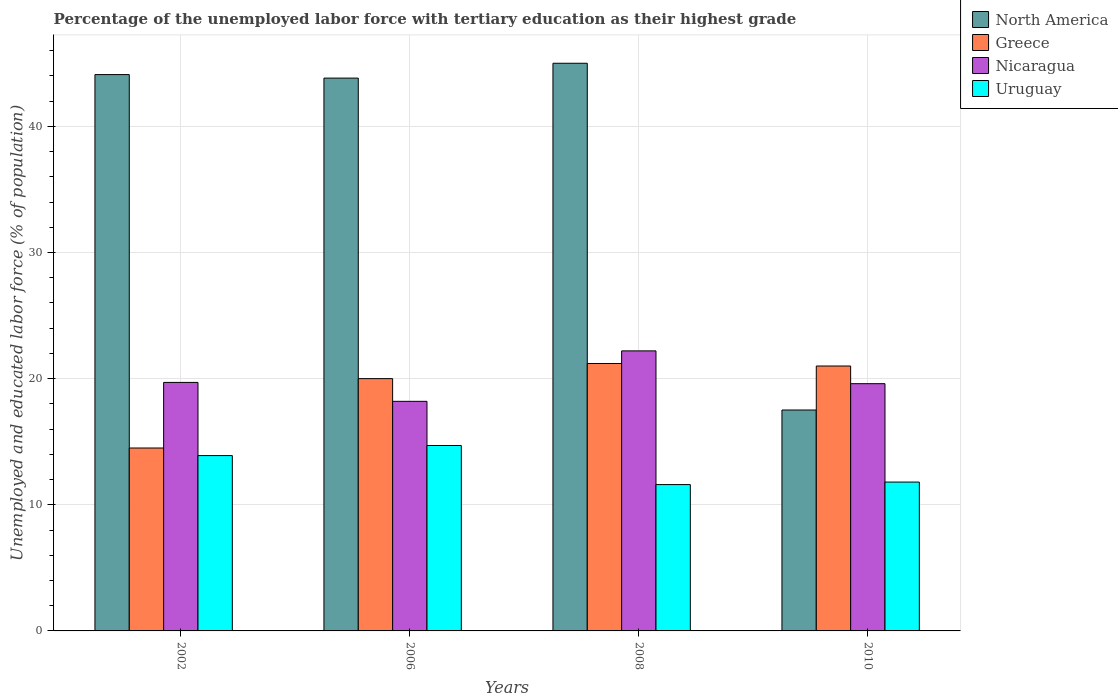How many groups of bars are there?
Ensure brevity in your answer.  4. Are the number of bars on each tick of the X-axis equal?
Make the answer very short. Yes. How many bars are there on the 1st tick from the right?
Your response must be concise. 4. What is the percentage of the unemployed labor force with tertiary education in Greece in 2008?
Provide a short and direct response. 21.2. Across all years, what is the maximum percentage of the unemployed labor force with tertiary education in North America?
Your response must be concise. 45. Across all years, what is the minimum percentage of the unemployed labor force with tertiary education in Nicaragua?
Make the answer very short. 18.2. In which year was the percentage of the unemployed labor force with tertiary education in Uruguay minimum?
Your answer should be very brief. 2008. What is the total percentage of the unemployed labor force with tertiary education in North America in the graph?
Your answer should be compact. 150.44. What is the difference between the percentage of the unemployed labor force with tertiary education in North America in 2002 and that in 2010?
Ensure brevity in your answer.  26.59. What is the difference between the percentage of the unemployed labor force with tertiary education in Nicaragua in 2006 and the percentage of the unemployed labor force with tertiary education in Greece in 2002?
Keep it short and to the point. 3.7. What is the average percentage of the unemployed labor force with tertiary education in Nicaragua per year?
Your answer should be compact. 19.93. In the year 2008, what is the difference between the percentage of the unemployed labor force with tertiary education in Uruguay and percentage of the unemployed labor force with tertiary education in Nicaragua?
Keep it short and to the point. -10.6. In how many years, is the percentage of the unemployed labor force with tertiary education in Uruguay greater than 26 %?
Provide a short and direct response. 0. What is the ratio of the percentage of the unemployed labor force with tertiary education in Greece in 2002 to that in 2010?
Offer a very short reply. 0.69. Is the percentage of the unemployed labor force with tertiary education in Nicaragua in 2008 less than that in 2010?
Give a very brief answer. No. Is the difference between the percentage of the unemployed labor force with tertiary education in Uruguay in 2008 and 2010 greater than the difference between the percentage of the unemployed labor force with tertiary education in Nicaragua in 2008 and 2010?
Ensure brevity in your answer.  No. What is the difference between the highest and the second highest percentage of the unemployed labor force with tertiary education in Nicaragua?
Give a very brief answer. 2.5. What is the difference between the highest and the lowest percentage of the unemployed labor force with tertiary education in Uruguay?
Give a very brief answer. 3.1. In how many years, is the percentage of the unemployed labor force with tertiary education in Nicaragua greater than the average percentage of the unemployed labor force with tertiary education in Nicaragua taken over all years?
Offer a terse response. 1. Is the sum of the percentage of the unemployed labor force with tertiary education in Greece in 2006 and 2008 greater than the maximum percentage of the unemployed labor force with tertiary education in North America across all years?
Keep it short and to the point. No. Is it the case that in every year, the sum of the percentage of the unemployed labor force with tertiary education in Uruguay and percentage of the unemployed labor force with tertiary education in North America is greater than the sum of percentage of the unemployed labor force with tertiary education in Nicaragua and percentage of the unemployed labor force with tertiary education in Greece?
Give a very brief answer. No. What does the 3rd bar from the left in 2010 represents?
Ensure brevity in your answer.  Nicaragua. What does the 4th bar from the right in 2008 represents?
Your answer should be compact. North America. How many years are there in the graph?
Provide a short and direct response. 4. Are the values on the major ticks of Y-axis written in scientific E-notation?
Your answer should be compact. No. Does the graph contain any zero values?
Your response must be concise. No. Where does the legend appear in the graph?
Provide a succinct answer. Top right. How many legend labels are there?
Your response must be concise. 4. What is the title of the graph?
Your response must be concise. Percentage of the unemployed labor force with tertiary education as their highest grade. Does "Spain" appear as one of the legend labels in the graph?
Your answer should be compact. No. What is the label or title of the Y-axis?
Provide a succinct answer. Unemployed and educated labor force (% of population). What is the Unemployed and educated labor force (% of population) in North America in 2002?
Make the answer very short. 44.1. What is the Unemployed and educated labor force (% of population) in Greece in 2002?
Your answer should be compact. 14.5. What is the Unemployed and educated labor force (% of population) in Nicaragua in 2002?
Offer a terse response. 19.7. What is the Unemployed and educated labor force (% of population) of Uruguay in 2002?
Offer a terse response. 13.9. What is the Unemployed and educated labor force (% of population) of North America in 2006?
Offer a very short reply. 43.82. What is the Unemployed and educated labor force (% of population) in Nicaragua in 2006?
Ensure brevity in your answer.  18.2. What is the Unemployed and educated labor force (% of population) of Uruguay in 2006?
Keep it short and to the point. 14.7. What is the Unemployed and educated labor force (% of population) in North America in 2008?
Offer a terse response. 45. What is the Unemployed and educated labor force (% of population) in Greece in 2008?
Offer a very short reply. 21.2. What is the Unemployed and educated labor force (% of population) in Nicaragua in 2008?
Provide a short and direct response. 22.2. What is the Unemployed and educated labor force (% of population) of Uruguay in 2008?
Your response must be concise. 11.6. What is the Unemployed and educated labor force (% of population) of North America in 2010?
Ensure brevity in your answer.  17.51. What is the Unemployed and educated labor force (% of population) in Nicaragua in 2010?
Offer a very short reply. 19.6. What is the Unemployed and educated labor force (% of population) of Uruguay in 2010?
Give a very brief answer. 11.8. Across all years, what is the maximum Unemployed and educated labor force (% of population) in North America?
Keep it short and to the point. 45. Across all years, what is the maximum Unemployed and educated labor force (% of population) of Greece?
Ensure brevity in your answer.  21.2. Across all years, what is the maximum Unemployed and educated labor force (% of population) in Nicaragua?
Provide a succinct answer. 22.2. Across all years, what is the maximum Unemployed and educated labor force (% of population) of Uruguay?
Give a very brief answer. 14.7. Across all years, what is the minimum Unemployed and educated labor force (% of population) in North America?
Your response must be concise. 17.51. Across all years, what is the minimum Unemployed and educated labor force (% of population) in Nicaragua?
Provide a succinct answer. 18.2. Across all years, what is the minimum Unemployed and educated labor force (% of population) in Uruguay?
Ensure brevity in your answer.  11.6. What is the total Unemployed and educated labor force (% of population) in North America in the graph?
Your answer should be very brief. 150.44. What is the total Unemployed and educated labor force (% of population) of Greece in the graph?
Ensure brevity in your answer.  76.7. What is the total Unemployed and educated labor force (% of population) of Nicaragua in the graph?
Offer a very short reply. 79.7. What is the total Unemployed and educated labor force (% of population) of Uruguay in the graph?
Offer a very short reply. 52. What is the difference between the Unemployed and educated labor force (% of population) of North America in 2002 and that in 2006?
Give a very brief answer. 0.28. What is the difference between the Unemployed and educated labor force (% of population) of Greece in 2002 and that in 2006?
Make the answer very short. -5.5. What is the difference between the Unemployed and educated labor force (% of population) of North America in 2002 and that in 2008?
Your answer should be compact. -0.9. What is the difference between the Unemployed and educated labor force (% of population) of Greece in 2002 and that in 2008?
Give a very brief answer. -6.7. What is the difference between the Unemployed and educated labor force (% of population) of Uruguay in 2002 and that in 2008?
Give a very brief answer. 2.3. What is the difference between the Unemployed and educated labor force (% of population) in North America in 2002 and that in 2010?
Offer a terse response. 26.59. What is the difference between the Unemployed and educated labor force (% of population) of Greece in 2002 and that in 2010?
Your answer should be compact. -6.5. What is the difference between the Unemployed and educated labor force (% of population) of Nicaragua in 2002 and that in 2010?
Ensure brevity in your answer.  0.1. What is the difference between the Unemployed and educated labor force (% of population) in Uruguay in 2002 and that in 2010?
Provide a short and direct response. 2.1. What is the difference between the Unemployed and educated labor force (% of population) in North America in 2006 and that in 2008?
Your answer should be compact. -1.18. What is the difference between the Unemployed and educated labor force (% of population) in Nicaragua in 2006 and that in 2008?
Your response must be concise. -4. What is the difference between the Unemployed and educated labor force (% of population) in North America in 2006 and that in 2010?
Your response must be concise. 26.31. What is the difference between the Unemployed and educated labor force (% of population) of North America in 2008 and that in 2010?
Ensure brevity in your answer.  27.49. What is the difference between the Unemployed and educated labor force (% of population) of Greece in 2008 and that in 2010?
Keep it short and to the point. 0.2. What is the difference between the Unemployed and educated labor force (% of population) of North America in 2002 and the Unemployed and educated labor force (% of population) of Greece in 2006?
Your answer should be very brief. 24.1. What is the difference between the Unemployed and educated labor force (% of population) in North America in 2002 and the Unemployed and educated labor force (% of population) in Nicaragua in 2006?
Give a very brief answer. 25.9. What is the difference between the Unemployed and educated labor force (% of population) of North America in 2002 and the Unemployed and educated labor force (% of population) of Uruguay in 2006?
Keep it short and to the point. 29.4. What is the difference between the Unemployed and educated labor force (% of population) in Greece in 2002 and the Unemployed and educated labor force (% of population) in Uruguay in 2006?
Give a very brief answer. -0.2. What is the difference between the Unemployed and educated labor force (% of population) of Nicaragua in 2002 and the Unemployed and educated labor force (% of population) of Uruguay in 2006?
Ensure brevity in your answer.  5. What is the difference between the Unemployed and educated labor force (% of population) of North America in 2002 and the Unemployed and educated labor force (% of population) of Greece in 2008?
Ensure brevity in your answer.  22.9. What is the difference between the Unemployed and educated labor force (% of population) in North America in 2002 and the Unemployed and educated labor force (% of population) in Nicaragua in 2008?
Your answer should be very brief. 21.9. What is the difference between the Unemployed and educated labor force (% of population) of North America in 2002 and the Unemployed and educated labor force (% of population) of Uruguay in 2008?
Your answer should be compact. 32.5. What is the difference between the Unemployed and educated labor force (% of population) of North America in 2002 and the Unemployed and educated labor force (% of population) of Greece in 2010?
Your answer should be very brief. 23.1. What is the difference between the Unemployed and educated labor force (% of population) in North America in 2002 and the Unemployed and educated labor force (% of population) in Nicaragua in 2010?
Offer a very short reply. 24.5. What is the difference between the Unemployed and educated labor force (% of population) in North America in 2002 and the Unemployed and educated labor force (% of population) in Uruguay in 2010?
Your answer should be compact. 32.3. What is the difference between the Unemployed and educated labor force (% of population) in North America in 2006 and the Unemployed and educated labor force (% of population) in Greece in 2008?
Provide a succinct answer. 22.62. What is the difference between the Unemployed and educated labor force (% of population) in North America in 2006 and the Unemployed and educated labor force (% of population) in Nicaragua in 2008?
Offer a very short reply. 21.62. What is the difference between the Unemployed and educated labor force (% of population) in North America in 2006 and the Unemployed and educated labor force (% of population) in Uruguay in 2008?
Make the answer very short. 32.22. What is the difference between the Unemployed and educated labor force (% of population) of Greece in 2006 and the Unemployed and educated labor force (% of population) of Nicaragua in 2008?
Offer a very short reply. -2.2. What is the difference between the Unemployed and educated labor force (% of population) of Nicaragua in 2006 and the Unemployed and educated labor force (% of population) of Uruguay in 2008?
Give a very brief answer. 6.6. What is the difference between the Unemployed and educated labor force (% of population) in North America in 2006 and the Unemployed and educated labor force (% of population) in Greece in 2010?
Provide a short and direct response. 22.82. What is the difference between the Unemployed and educated labor force (% of population) in North America in 2006 and the Unemployed and educated labor force (% of population) in Nicaragua in 2010?
Offer a terse response. 24.22. What is the difference between the Unemployed and educated labor force (% of population) in North America in 2006 and the Unemployed and educated labor force (% of population) in Uruguay in 2010?
Your answer should be compact. 32.02. What is the difference between the Unemployed and educated labor force (% of population) in Greece in 2006 and the Unemployed and educated labor force (% of population) in Nicaragua in 2010?
Make the answer very short. 0.4. What is the difference between the Unemployed and educated labor force (% of population) of Nicaragua in 2006 and the Unemployed and educated labor force (% of population) of Uruguay in 2010?
Offer a very short reply. 6.4. What is the difference between the Unemployed and educated labor force (% of population) in North America in 2008 and the Unemployed and educated labor force (% of population) in Greece in 2010?
Give a very brief answer. 24. What is the difference between the Unemployed and educated labor force (% of population) in North America in 2008 and the Unemployed and educated labor force (% of population) in Nicaragua in 2010?
Make the answer very short. 25.4. What is the difference between the Unemployed and educated labor force (% of population) of North America in 2008 and the Unemployed and educated labor force (% of population) of Uruguay in 2010?
Your answer should be very brief. 33.2. What is the difference between the Unemployed and educated labor force (% of population) of Greece in 2008 and the Unemployed and educated labor force (% of population) of Uruguay in 2010?
Ensure brevity in your answer.  9.4. What is the difference between the Unemployed and educated labor force (% of population) in Nicaragua in 2008 and the Unemployed and educated labor force (% of population) in Uruguay in 2010?
Provide a short and direct response. 10.4. What is the average Unemployed and educated labor force (% of population) of North America per year?
Your response must be concise. 37.61. What is the average Unemployed and educated labor force (% of population) in Greece per year?
Offer a very short reply. 19.18. What is the average Unemployed and educated labor force (% of population) in Nicaragua per year?
Make the answer very short. 19.93. What is the average Unemployed and educated labor force (% of population) in Uruguay per year?
Your answer should be compact. 13. In the year 2002, what is the difference between the Unemployed and educated labor force (% of population) in North America and Unemployed and educated labor force (% of population) in Greece?
Your response must be concise. 29.6. In the year 2002, what is the difference between the Unemployed and educated labor force (% of population) of North America and Unemployed and educated labor force (% of population) of Nicaragua?
Keep it short and to the point. 24.4. In the year 2002, what is the difference between the Unemployed and educated labor force (% of population) in North America and Unemployed and educated labor force (% of population) in Uruguay?
Offer a terse response. 30.2. In the year 2006, what is the difference between the Unemployed and educated labor force (% of population) in North America and Unemployed and educated labor force (% of population) in Greece?
Ensure brevity in your answer.  23.82. In the year 2006, what is the difference between the Unemployed and educated labor force (% of population) of North America and Unemployed and educated labor force (% of population) of Nicaragua?
Provide a succinct answer. 25.62. In the year 2006, what is the difference between the Unemployed and educated labor force (% of population) of North America and Unemployed and educated labor force (% of population) of Uruguay?
Provide a succinct answer. 29.12. In the year 2006, what is the difference between the Unemployed and educated labor force (% of population) in Greece and Unemployed and educated labor force (% of population) in Nicaragua?
Offer a very short reply. 1.8. In the year 2006, what is the difference between the Unemployed and educated labor force (% of population) of Greece and Unemployed and educated labor force (% of population) of Uruguay?
Your response must be concise. 5.3. In the year 2006, what is the difference between the Unemployed and educated labor force (% of population) in Nicaragua and Unemployed and educated labor force (% of population) in Uruguay?
Give a very brief answer. 3.5. In the year 2008, what is the difference between the Unemployed and educated labor force (% of population) in North America and Unemployed and educated labor force (% of population) in Greece?
Give a very brief answer. 23.8. In the year 2008, what is the difference between the Unemployed and educated labor force (% of population) of North America and Unemployed and educated labor force (% of population) of Nicaragua?
Offer a terse response. 22.8. In the year 2008, what is the difference between the Unemployed and educated labor force (% of population) in North America and Unemployed and educated labor force (% of population) in Uruguay?
Your answer should be very brief. 33.4. In the year 2008, what is the difference between the Unemployed and educated labor force (% of population) in Nicaragua and Unemployed and educated labor force (% of population) in Uruguay?
Provide a succinct answer. 10.6. In the year 2010, what is the difference between the Unemployed and educated labor force (% of population) in North America and Unemployed and educated labor force (% of population) in Greece?
Make the answer very short. -3.49. In the year 2010, what is the difference between the Unemployed and educated labor force (% of population) of North America and Unemployed and educated labor force (% of population) of Nicaragua?
Provide a succinct answer. -2.09. In the year 2010, what is the difference between the Unemployed and educated labor force (% of population) of North America and Unemployed and educated labor force (% of population) of Uruguay?
Provide a succinct answer. 5.71. In the year 2010, what is the difference between the Unemployed and educated labor force (% of population) in Greece and Unemployed and educated labor force (% of population) in Nicaragua?
Your answer should be very brief. 1.4. In the year 2010, what is the difference between the Unemployed and educated labor force (% of population) in Greece and Unemployed and educated labor force (% of population) in Uruguay?
Give a very brief answer. 9.2. What is the ratio of the Unemployed and educated labor force (% of population) of North America in 2002 to that in 2006?
Offer a very short reply. 1.01. What is the ratio of the Unemployed and educated labor force (% of population) of Greece in 2002 to that in 2006?
Provide a short and direct response. 0.72. What is the ratio of the Unemployed and educated labor force (% of population) in Nicaragua in 2002 to that in 2006?
Your response must be concise. 1.08. What is the ratio of the Unemployed and educated labor force (% of population) in Uruguay in 2002 to that in 2006?
Keep it short and to the point. 0.95. What is the ratio of the Unemployed and educated labor force (% of population) of Greece in 2002 to that in 2008?
Offer a terse response. 0.68. What is the ratio of the Unemployed and educated labor force (% of population) in Nicaragua in 2002 to that in 2008?
Your answer should be compact. 0.89. What is the ratio of the Unemployed and educated labor force (% of population) of Uruguay in 2002 to that in 2008?
Offer a terse response. 1.2. What is the ratio of the Unemployed and educated labor force (% of population) in North America in 2002 to that in 2010?
Give a very brief answer. 2.52. What is the ratio of the Unemployed and educated labor force (% of population) of Greece in 2002 to that in 2010?
Provide a short and direct response. 0.69. What is the ratio of the Unemployed and educated labor force (% of population) in Nicaragua in 2002 to that in 2010?
Provide a short and direct response. 1.01. What is the ratio of the Unemployed and educated labor force (% of population) in Uruguay in 2002 to that in 2010?
Your answer should be compact. 1.18. What is the ratio of the Unemployed and educated labor force (% of population) in North America in 2006 to that in 2008?
Provide a succinct answer. 0.97. What is the ratio of the Unemployed and educated labor force (% of population) of Greece in 2006 to that in 2008?
Offer a terse response. 0.94. What is the ratio of the Unemployed and educated labor force (% of population) of Nicaragua in 2006 to that in 2008?
Your response must be concise. 0.82. What is the ratio of the Unemployed and educated labor force (% of population) of Uruguay in 2006 to that in 2008?
Provide a short and direct response. 1.27. What is the ratio of the Unemployed and educated labor force (% of population) in North America in 2006 to that in 2010?
Provide a succinct answer. 2.5. What is the ratio of the Unemployed and educated labor force (% of population) in Uruguay in 2006 to that in 2010?
Your response must be concise. 1.25. What is the ratio of the Unemployed and educated labor force (% of population) in North America in 2008 to that in 2010?
Your response must be concise. 2.57. What is the ratio of the Unemployed and educated labor force (% of population) in Greece in 2008 to that in 2010?
Give a very brief answer. 1.01. What is the ratio of the Unemployed and educated labor force (% of population) in Nicaragua in 2008 to that in 2010?
Keep it short and to the point. 1.13. What is the ratio of the Unemployed and educated labor force (% of population) of Uruguay in 2008 to that in 2010?
Offer a very short reply. 0.98. What is the difference between the highest and the second highest Unemployed and educated labor force (% of population) of North America?
Make the answer very short. 0.9. What is the difference between the highest and the second highest Unemployed and educated labor force (% of population) in Greece?
Give a very brief answer. 0.2. What is the difference between the highest and the second highest Unemployed and educated labor force (% of population) in Nicaragua?
Give a very brief answer. 2.5. What is the difference between the highest and the second highest Unemployed and educated labor force (% of population) in Uruguay?
Provide a succinct answer. 0.8. What is the difference between the highest and the lowest Unemployed and educated labor force (% of population) of North America?
Your response must be concise. 27.49. 